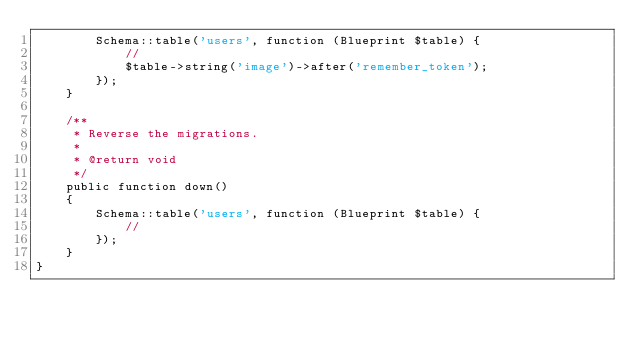Convert code to text. <code><loc_0><loc_0><loc_500><loc_500><_PHP_>        Schema::table('users', function (Blueprint $table) {
            //
            $table->string('image')->after('remember_token');
        });
    }

    /**
     * Reverse the migrations.
     *
     * @return void
     */
    public function down()
    {
        Schema::table('users', function (Blueprint $table) {
            //
        });
    }
}
</code> 